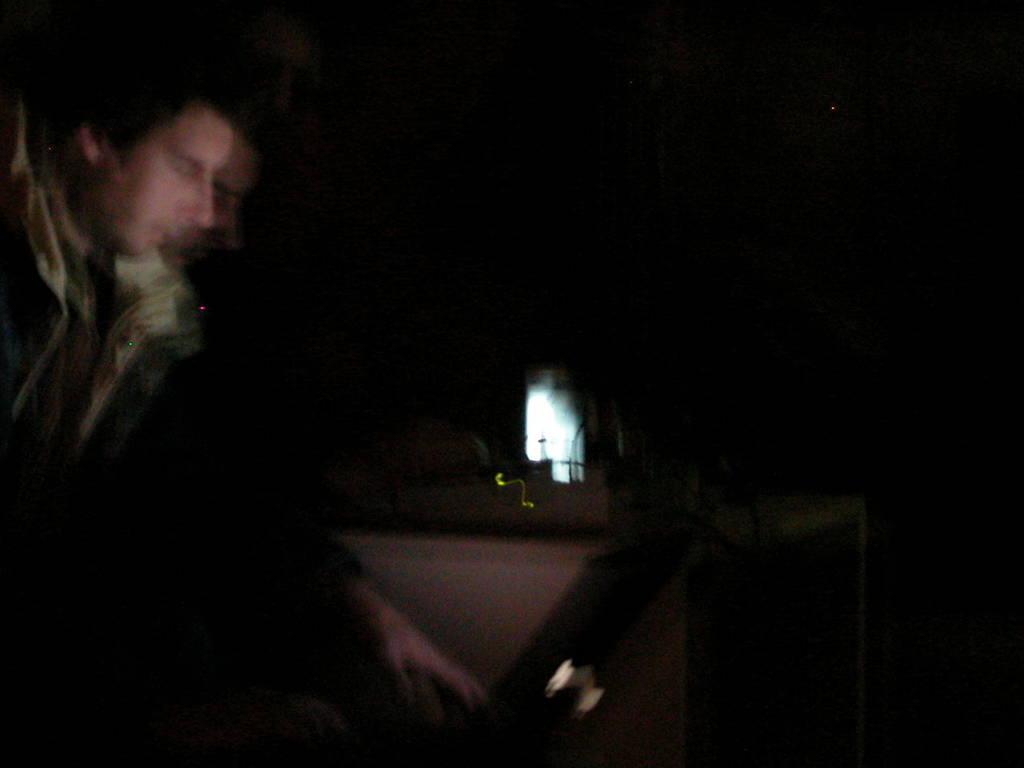In one or two sentences, can you explain what this image depicts? In the foreground of this image, there is a man and a laptop in the dark and the remaining objects are not clear. 